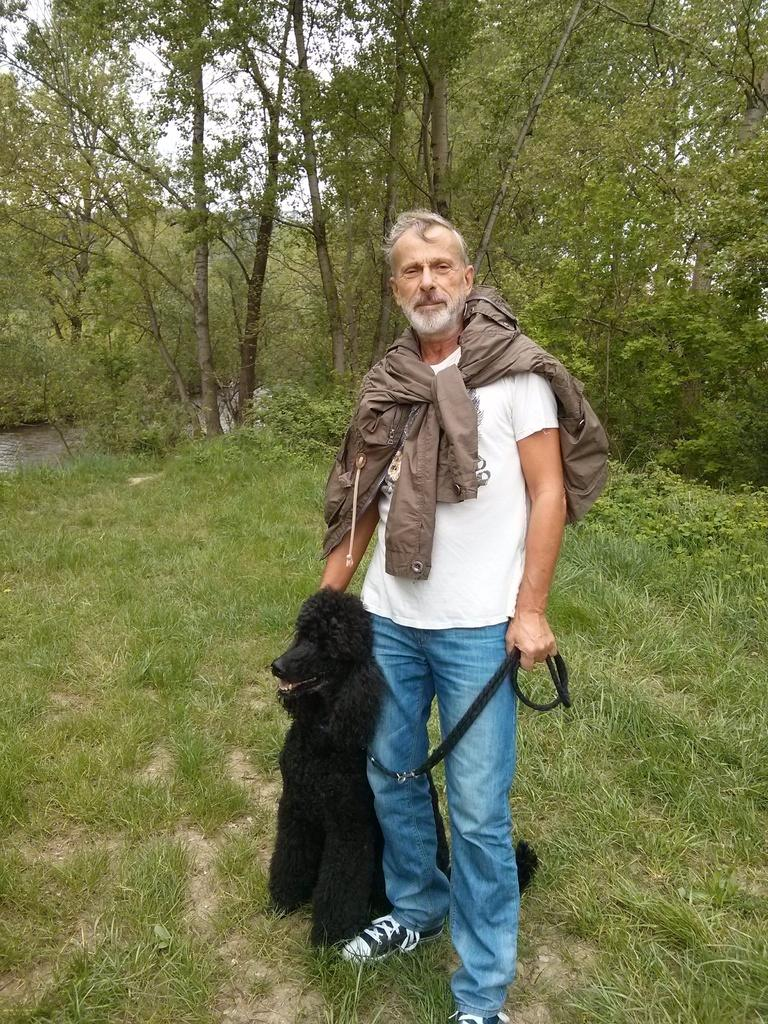Who is present in the image? There is a man in the image. What is the man wearing on his upper body? The man is wearing a white T-shirt and a jacket that extends to his neck. What is the man doing in the image? The man is holding a dog with his hand. What can be seen in the background of the image? There is a tree and the sky visible in the background of the image. What type of cherry is the man eating in the image? There is no cherry present in the image; the man is holding a dog with his hand. How many brothers does the man have, and are they present in the image? There is no information about the man's brothers in the image or the provided facts. 